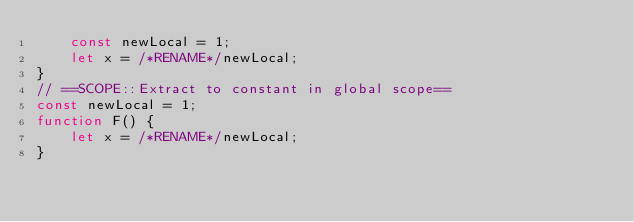Convert code to text. <code><loc_0><loc_0><loc_500><loc_500><_TypeScript_>    const newLocal = 1;
    let x = /*RENAME*/newLocal;
}
// ==SCOPE::Extract to constant in global scope==
const newLocal = 1;
function F() {
    let x = /*RENAME*/newLocal;
}</code> 